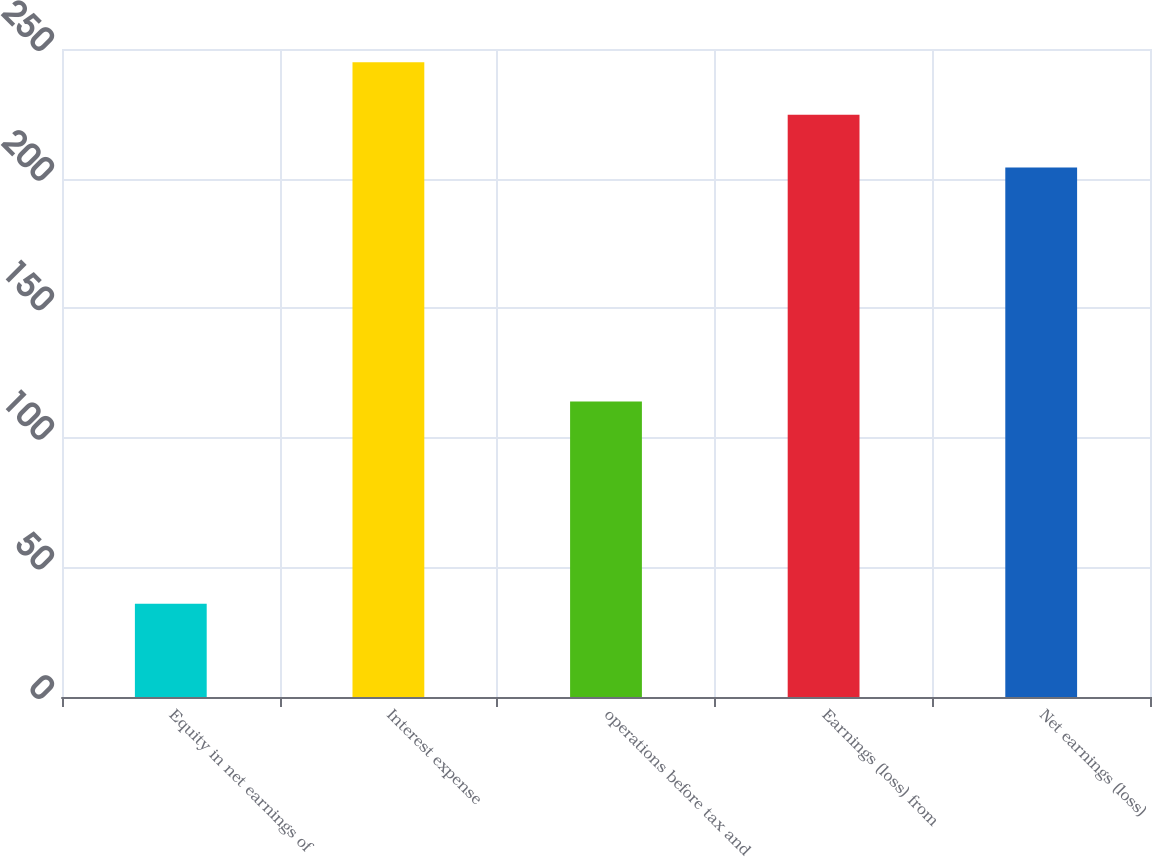Convert chart. <chart><loc_0><loc_0><loc_500><loc_500><bar_chart><fcel>Equity in net earnings of<fcel>Interest expense<fcel>operations before tax and<fcel>Earnings (loss) from<fcel>Net earnings (loss)<nl><fcel>36<fcel>244.9<fcel>114<fcel>224.6<fcel>204.3<nl></chart> 